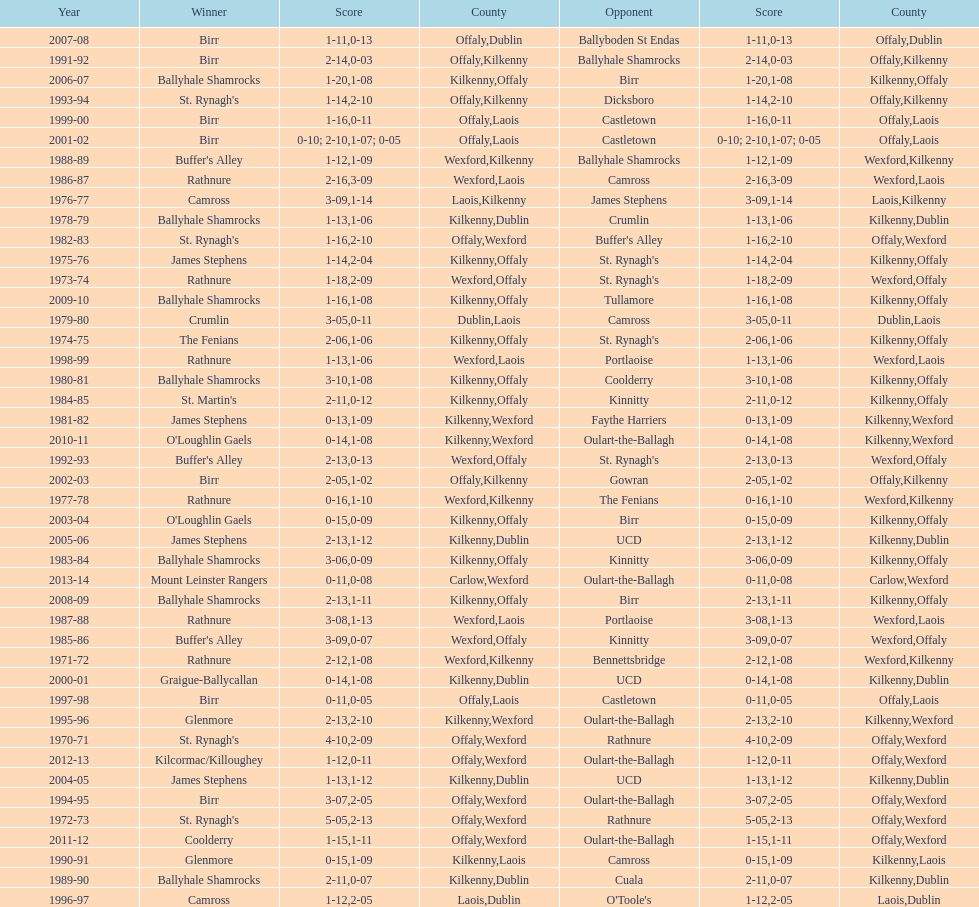What was the last season the leinster senior club hurling championships was won by a score differential of less than 11? 2007-08. 